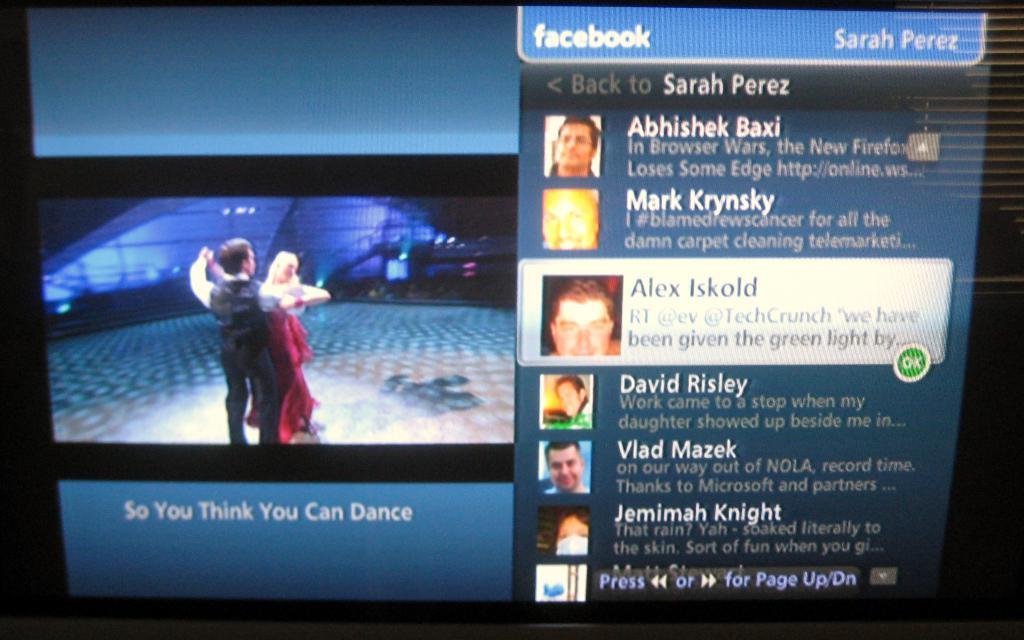In one or two sentences, can you explain what this image depicts? This picture shows a screenshot and we see a couple dancing on the floor and we see text. 